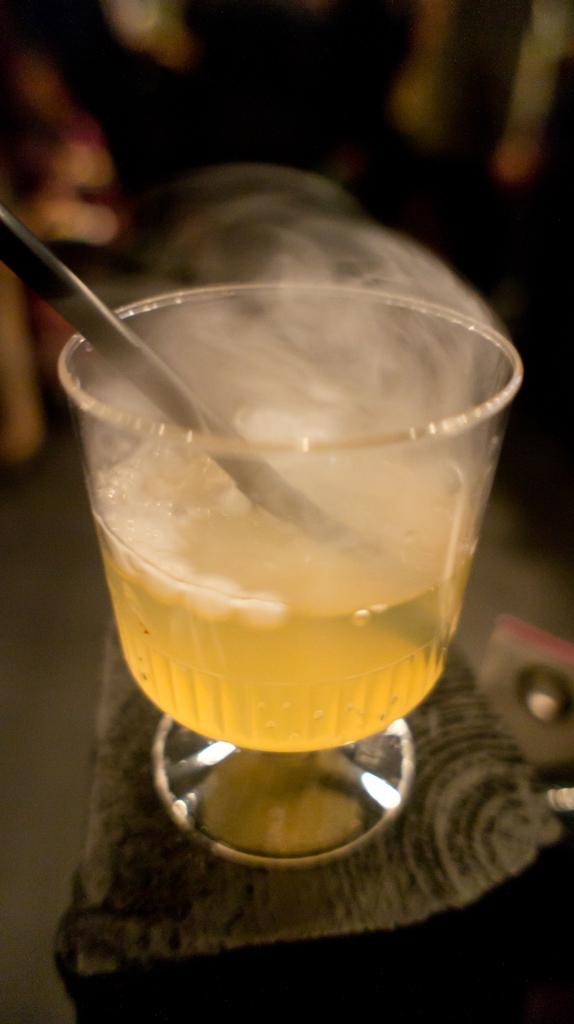What is in the bowl that is visible in the image? There is a bowl with liquid in the image. What is the bowl placed on? The bowl is on an object. Can you describe the background of the image? The background of the image is blurred. What religious text can be seen in the image? There is no religious text present in the image. What type of book is visible in the image? There is no book present in the image. Can you see any airplanes or airport-related structures in the image? There is no reference to an airport or airplanes in the image. 